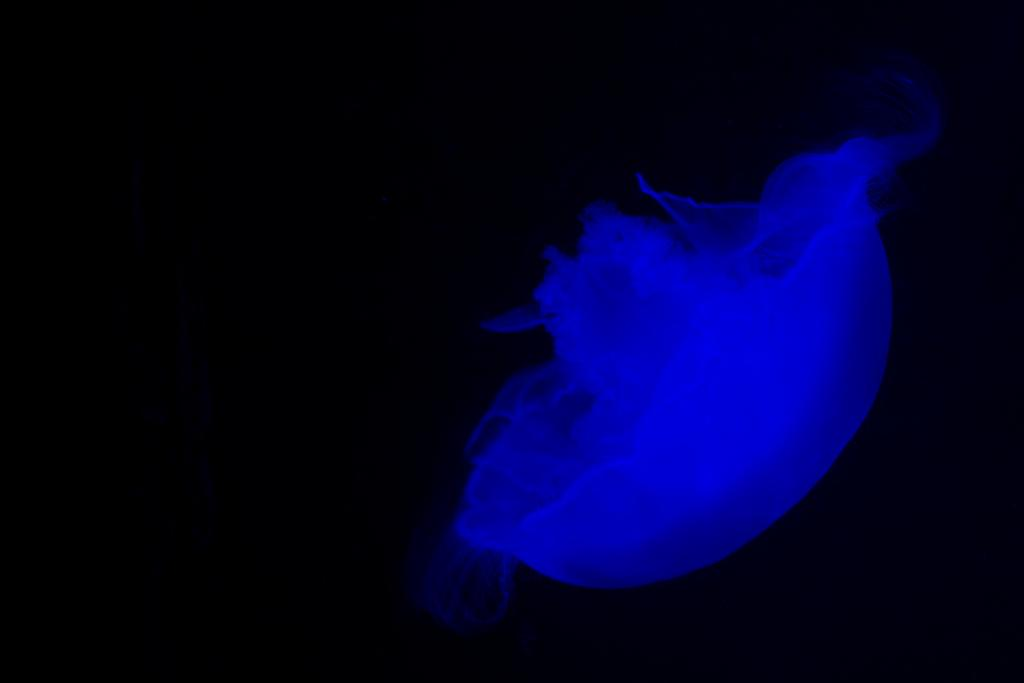What color is present in the image? There is an object or element in the image that is blue in color. How would you describe the overall appearance of the image? The overall view or background of the image is dark. Can you tell me how the earthquake affected the blue object in the image? There is no earthquake present in the image, so its effect on the blue object cannot be determined. What type of poison is visible on the blue object in the image? There is no poison present in the image, and therefore no such substance can be observed on the blue object. 